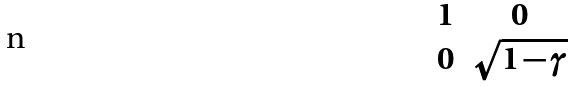<formula> <loc_0><loc_0><loc_500><loc_500>\begin{matrix} 1 & 0 \\ 0 & \sqrt { 1 - \gamma } \end{matrix}</formula> 